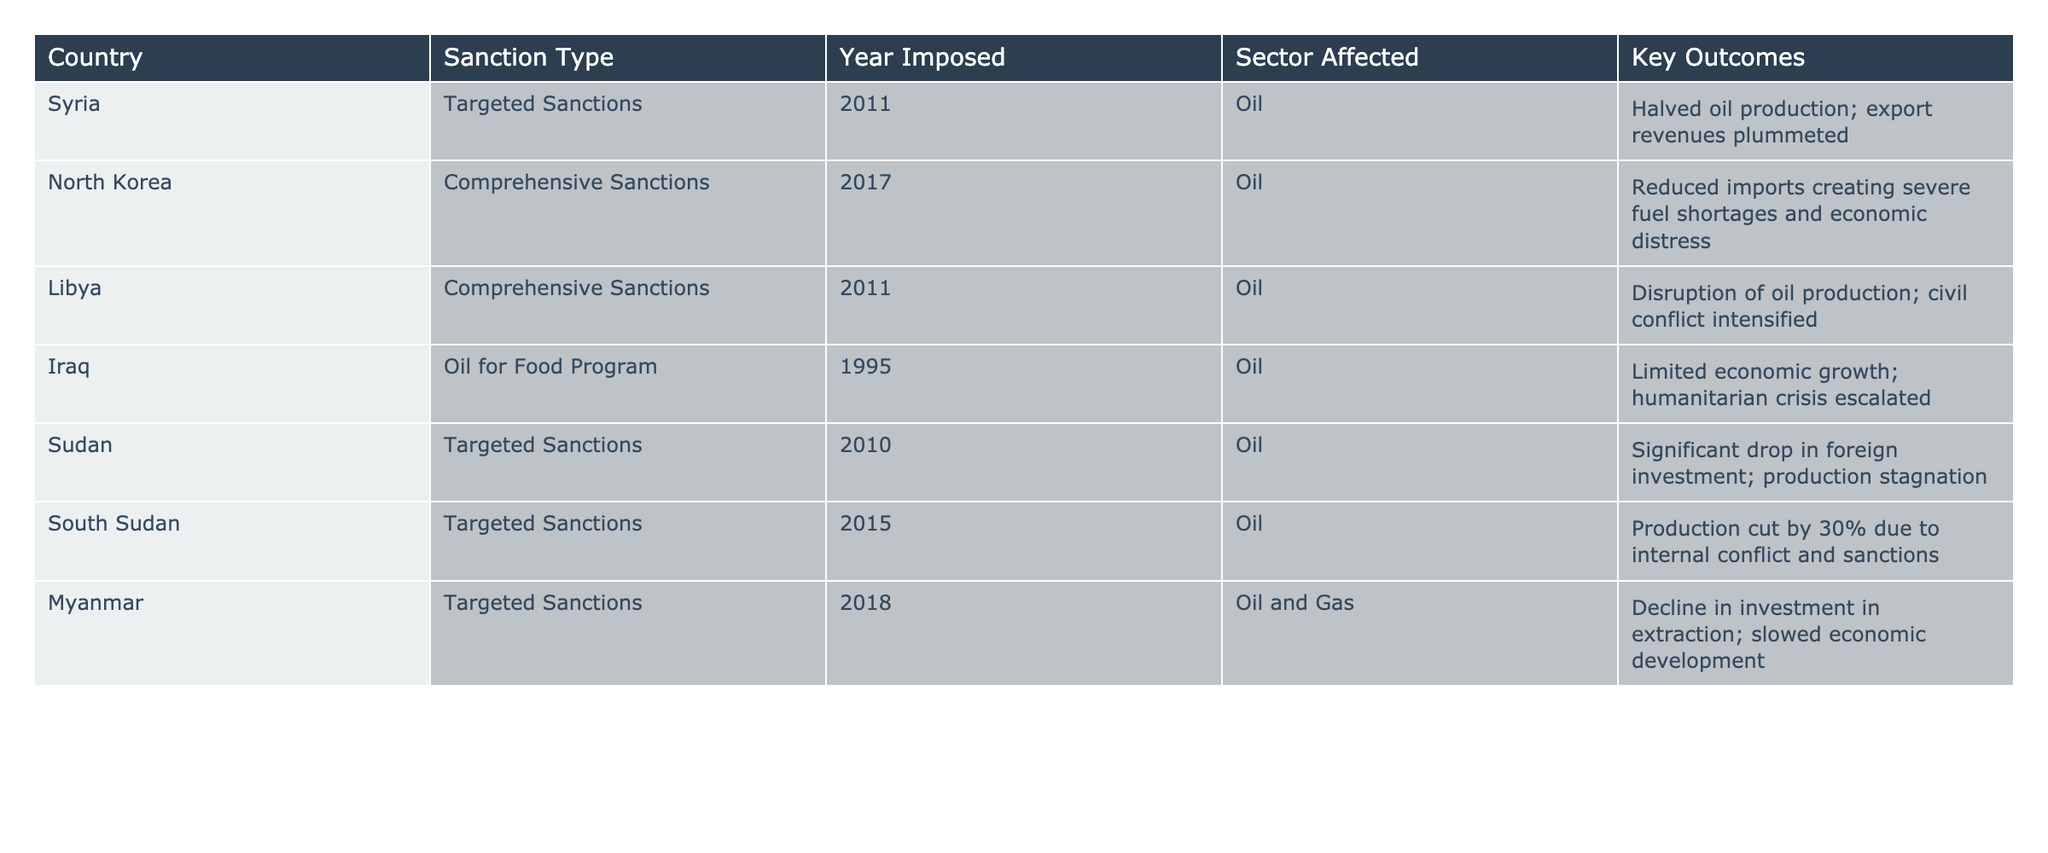What type of sanctions were imposed on Syria? The table specifies that Syria was subjected to "Targeted Sanctions" in 2011.
Answer: Targeted Sanctions Which country's oil sector experienced a decline in investment due to targeted sanctions? The table shows that Myanmar's oil and gas sector faced a decline in investment owing to targeted sanctions imposed in 2018.
Answer: Myanmar How many years after the imposition of sanctions did South Sudan cut its oil production by 30%? South Sudan’s sanctions were imposed in 2015, and they cut production subsequently. The table doesn’t provide specific duration between sanctions and production cut, but it implies the effect followed soon after the sanctions.
Answer: It is implied to be shortly after the sanctions Which country faced comprehensive sanctions in 2011 and experienced disruption in oil production? The table indicates that Libya faced comprehensive sanctions in 2011, which led to a disruption in oil production according to the key outcomes.
Answer: Libya What is the key outcome of the oil for food program imposed on Iraq? The table states that the oil for food program led to limited economic growth and an escalation of the humanitarian crisis in Iraq.
Answer: Limited economic growth and humanitarian crisis Which two countries had targeted sanctions imposed on them before 2015? Referring to the table, Syria (2011) and Sudan (2010) are the two countries under targeted sanctions before 2015.
Answer: Syria and Sudan What sector was affected by the comprehensive sanctions imposed on North Korea in 2017? The table clearly states that the oil sector was affected by the comprehensive sanctions imposed on North Korea in 2017.
Answer: Oil How did the imposition of sanctions affect oil production in Syria? According to the table, the imposition of targeted sanctions on Syria in 2011 halved its oil production and led to plunging export revenues.
Answer: Halved production and export revenues plummeted Which country had targeted sanctions in 2010 but did not experience a drop in oil production? The table lists Sudan as having targeted sanctions in 2010. However, it mentions a significant drop in foreign investment rather than production, indicating production levels were not specified as plummeting.
Answer: Sudan Was there any impact on economic development in Myanmar due to targeted sanctions? The data in the table indicates that Myanmar faced a decline in investment in extraction, which suggests that economic development was indeed slowed.
Answer: Yes Can you summarize the key outcomes of the comprehensive sanctions on Libya? The table states the key outcomes included a disruption of oil production and an intensification of civil conflict in Libya.
Answer: Disrupted oil production; civil conflict intensified 